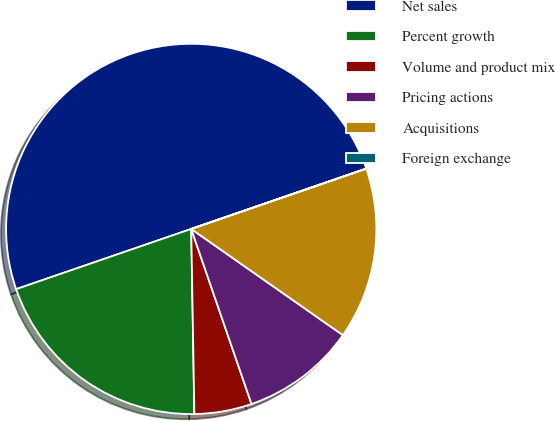Convert chart to OTSL. <chart><loc_0><loc_0><loc_500><loc_500><pie_chart><fcel>Net sales<fcel>Percent growth<fcel>Volume and product mix<fcel>Pricing actions<fcel>Acquisitions<fcel>Foreign exchange<nl><fcel>49.99%<fcel>20.0%<fcel>5.01%<fcel>10.0%<fcel>15.0%<fcel>0.01%<nl></chart> 